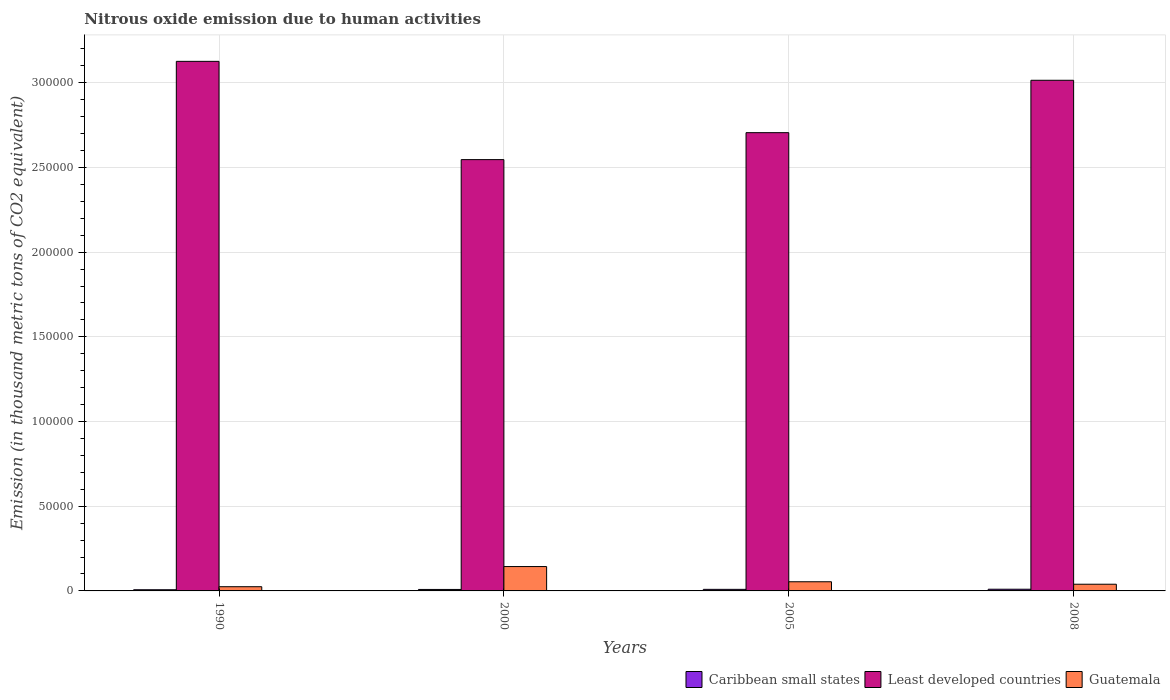How many different coloured bars are there?
Offer a very short reply. 3. How many groups of bars are there?
Your answer should be very brief. 4. Are the number of bars per tick equal to the number of legend labels?
Provide a short and direct response. Yes. Are the number of bars on each tick of the X-axis equal?
Offer a terse response. Yes. How many bars are there on the 1st tick from the left?
Your answer should be compact. 3. How many bars are there on the 4th tick from the right?
Your answer should be compact. 3. What is the amount of nitrous oxide emitted in Guatemala in 1990?
Provide a short and direct response. 2483.4. Across all years, what is the maximum amount of nitrous oxide emitted in Guatemala?
Your response must be concise. 1.44e+04. Across all years, what is the minimum amount of nitrous oxide emitted in Caribbean small states?
Your answer should be very brief. 699.1. In which year was the amount of nitrous oxide emitted in Guatemala maximum?
Offer a terse response. 2000. In which year was the amount of nitrous oxide emitted in Guatemala minimum?
Provide a succinct answer. 1990. What is the total amount of nitrous oxide emitted in Caribbean small states in the graph?
Your answer should be very brief. 3493.5. What is the difference between the amount of nitrous oxide emitted in Guatemala in 2005 and that in 2008?
Your answer should be compact. 1462.9. What is the difference between the amount of nitrous oxide emitted in Least developed countries in 2008 and the amount of nitrous oxide emitted in Guatemala in 2000?
Provide a short and direct response. 2.87e+05. What is the average amount of nitrous oxide emitted in Least developed countries per year?
Offer a terse response. 2.85e+05. In the year 2005, what is the difference between the amount of nitrous oxide emitted in Guatemala and amount of nitrous oxide emitted in Caribbean small states?
Offer a terse response. 4489.8. In how many years, is the amount of nitrous oxide emitted in Guatemala greater than 80000 thousand metric tons?
Give a very brief answer. 0. What is the ratio of the amount of nitrous oxide emitted in Caribbean small states in 1990 to that in 2008?
Keep it short and to the point. 0.7. What is the difference between the highest and the second highest amount of nitrous oxide emitted in Guatemala?
Your response must be concise. 8972.6. What is the difference between the highest and the lowest amount of nitrous oxide emitted in Caribbean small states?
Offer a very short reply. 304.3. In how many years, is the amount of nitrous oxide emitted in Least developed countries greater than the average amount of nitrous oxide emitted in Least developed countries taken over all years?
Provide a short and direct response. 2. What does the 3rd bar from the left in 2008 represents?
Make the answer very short. Guatemala. What does the 2nd bar from the right in 1990 represents?
Offer a very short reply. Least developed countries. Is it the case that in every year, the sum of the amount of nitrous oxide emitted in Least developed countries and amount of nitrous oxide emitted in Guatemala is greater than the amount of nitrous oxide emitted in Caribbean small states?
Provide a succinct answer. Yes. How many bars are there?
Offer a very short reply. 12. How many years are there in the graph?
Make the answer very short. 4. What is the difference between two consecutive major ticks on the Y-axis?
Provide a succinct answer. 5.00e+04. Does the graph contain grids?
Provide a short and direct response. Yes. Where does the legend appear in the graph?
Ensure brevity in your answer.  Bottom right. How many legend labels are there?
Your response must be concise. 3. How are the legend labels stacked?
Keep it short and to the point. Horizontal. What is the title of the graph?
Offer a very short reply. Nitrous oxide emission due to human activities. What is the label or title of the Y-axis?
Provide a succinct answer. Emission (in thousand metric tons of CO2 equivalent). What is the Emission (in thousand metric tons of CO2 equivalent) of Caribbean small states in 1990?
Offer a very short reply. 699.1. What is the Emission (in thousand metric tons of CO2 equivalent) in Least developed countries in 1990?
Keep it short and to the point. 3.13e+05. What is the Emission (in thousand metric tons of CO2 equivalent) of Guatemala in 1990?
Your answer should be compact. 2483.4. What is the Emission (in thousand metric tons of CO2 equivalent) of Caribbean small states in 2000?
Your response must be concise. 867.7. What is the Emission (in thousand metric tons of CO2 equivalent) in Least developed countries in 2000?
Provide a succinct answer. 2.55e+05. What is the Emission (in thousand metric tons of CO2 equivalent) of Guatemala in 2000?
Ensure brevity in your answer.  1.44e+04. What is the Emission (in thousand metric tons of CO2 equivalent) in Caribbean small states in 2005?
Provide a succinct answer. 923.3. What is the Emission (in thousand metric tons of CO2 equivalent) of Least developed countries in 2005?
Offer a very short reply. 2.71e+05. What is the Emission (in thousand metric tons of CO2 equivalent) in Guatemala in 2005?
Ensure brevity in your answer.  5413.1. What is the Emission (in thousand metric tons of CO2 equivalent) in Caribbean small states in 2008?
Your response must be concise. 1003.4. What is the Emission (in thousand metric tons of CO2 equivalent) of Least developed countries in 2008?
Offer a very short reply. 3.02e+05. What is the Emission (in thousand metric tons of CO2 equivalent) in Guatemala in 2008?
Your answer should be compact. 3950.2. Across all years, what is the maximum Emission (in thousand metric tons of CO2 equivalent) in Caribbean small states?
Make the answer very short. 1003.4. Across all years, what is the maximum Emission (in thousand metric tons of CO2 equivalent) in Least developed countries?
Your response must be concise. 3.13e+05. Across all years, what is the maximum Emission (in thousand metric tons of CO2 equivalent) in Guatemala?
Your answer should be compact. 1.44e+04. Across all years, what is the minimum Emission (in thousand metric tons of CO2 equivalent) of Caribbean small states?
Provide a succinct answer. 699.1. Across all years, what is the minimum Emission (in thousand metric tons of CO2 equivalent) of Least developed countries?
Your response must be concise. 2.55e+05. Across all years, what is the minimum Emission (in thousand metric tons of CO2 equivalent) in Guatemala?
Ensure brevity in your answer.  2483.4. What is the total Emission (in thousand metric tons of CO2 equivalent) in Caribbean small states in the graph?
Offer a terse response. 3493.5. What is the total Emission (in thousand metric tons of CO2 equivalent) of Least developed countries in the graph?
Offer a very short reply. 1.14e+06. What is the total Emission (in thousand metric tons of CO2 equivalent) of Guatemala in the graph?
Provide a short and direct response. 2.62e+04. What is the difference between the Emission (in thousand metric tons of CO2 equivalent) of Caribbean small states in 1990 and that in 2000?
Your answer should be compact. -168.6. What is the difference between the Emission (in thousand metric tons of CO2 equivalent) of Least developed countries in 1990 and that in 2000?
Your response must be concise. 5.80e+04. What is the difference between the Emission (in thousand metric tons of CO2 equivalent) in Guatemala in 1990 and that in 2000?
Make the answer very short. -1.19e+04. What is the difference between the Emission (in thousand metric tons of CO2 equivalent) of Caribbean small states in 1990 and that in 2005?
Your response must be concise. -224.2. What is the difference between the Emission (in thousand metric tons of CO2 equivalent) of Least developed countries in 1990 and that in 2005?
Provide a short and direct response. 4.21e+04. What is the difference between the Emission (in thousand metric tons of CO2 equivalent) of Guatemala in 1990 and that in 2005?
Offer a very short reply. -2929.7. What is the difference between the Emission (in thousand metric tons of CO2 equivalent) of Caribbean small states in 1990 and that in 2008?
Give a very brief answer. -304.3. What is the difference between the Emission (in thousand metric tons of CO2 equivalent) of Least developed countries in 1990 and that in 2008?
Give a very brief answer. 1.12e+04. What is the difference between the Emission (in thousand metric tons of CO2 equivalent) of Guatemala in 1990 and that in 2008?
Your response must be concise. -1466.8. What is the difference between the Emission (in thousand metric tons of CO2 equivalent) in Caribbean small states in 2000 and that in 2005?
Offer a very short reply. -55.6. What is the difference between the Emission (in thousand metric tons of CO2 equivalent) in Least developed countries in 2000 and that in 2005?
Ensure brevity in your answer.  -1.59e+04. What is the difference between the Emission (in thousand metric tons of CO2 equivalent) in Guatemala in 2000 and that in 2005?
Ensure brevity in your answer.  8972.6. What is the difference between the Emission (in thousand metric tons of CO2 equivalent) in Caribbean small states in 2000 and that in 2008?
Offer a terse response. -135.7. What is the difference between the Emission (in thousand metric tons of CO2 equivalent) in Least developed countries in 2000 and that in 2008?
Provide a succinct answer. -4.69e+04. What is the difference between the Emission (in thousand metric tons of CO2 equivalent) of Guatemala in 2000 and that in 2008?
Your answer should be very brief. 1.04e+04. What is the difference between the Emission (in thousand metric tons of CO2 equivalent) of Caribbean small states in 2005 and that in 2008?
Keep it short and to the point. -80.1. What is the difference between the Emission (in thousand metric tons of CO2 equivalent) of Least developed countries in 2005 and that in 2008?
Offer a very short reply. -3.09e+04. What is the difference between the Emission (in thousand metric tons of CO2 equivalent) in Guatemala in 2005 and that in 2008?
Give a very brief answer. 1462.9. What is the difference between the Emission (in thousand metric tons of CO2 equivalent) of Caribbean small states in 1990 and the Emission (in thousand metric tons of CO2 equivalent) of Least developed countries in 2000?
Ensure brevity in your answer.  -2.54e+05. What is the difference between the Emission (in thousand metric tons of CO2 equivalent) of Caribbean small states in 1990 and the Emission (in thousand metric tons of CO2 equivalent) of Guatemala in 2000?
Provide a succinct answer. -1.37e+04. What is the difference between the Emission (in thousand metric tons of CO2 equivalent) of Least developed countries in 1990 and the Emission (in thousand metric tons of CO2 equivalent) of Guatemala in 2000?
Offer a very short reply. 2.98e+05. What is the difference between the Emission (in thousand metric tons of CO2 equivalent) of Caribbean small states in 1990 and the Emission (in thousand metric tons of CO2 equivalent) of Least developed countries in 2005?
Offer a terse response. -2.70e+05. What is the difference between the Emission (in thousand metric tons of CO2 equivalent) in Caribbean small states in 1990 and the Emission (in thousand metric tons of CO2 equivalent) in Guatemala in 2005?
Provide a short and direct response. -4714. What is the difference between the Emission (in thousand metric tons of CO2 equivalent) of Least developed countries in 1990 and the Emission (in thousand metric tons of CO2 equivalent) of Guatemala in 2005?
Offer a very short reply. 3.07e+05. What is the difference between the Emission (in thousand metric tons of CO2 equivalent) in Caribbean small states in 1990 and the Emission (in thousand metric tons of CO2 equivalent) in Least developed countries in 2008?
Your answer should be very brief. -3.01e+05. What is the difference between the Emission (in thousand metric tons of CO2 equivalent) in Caribbean small states in 1990 and the Emission (in thousand metric tons of CO2 equivalent) in Guatemala in 2008?
Ensure brevity in your answer.  -3251.1. What is the difference between the Emission (in thousand metric tons of CO2 equivalent) in Least developed countries in 1990 and the Emission (in thousand metric tons of CO2 equivalent) in Guatemala in 2008?
Keep it short and to the point. 3.09e+05. What is the difference between the Emission (in thousand metric tons of CO2 equivalent) of Caribbean small states in 2000 and the Emission (in thousand metric tons of CO2 equivalent) of Least developed countries in 2005?
Your answer should be very brief. -2.70e+05. What is the difference between the Emission (in thousand metric tons of CO2 equivalent) of Caribbean small states in 2000 and the Emission (in thousand metric tons of CO2 equivalent) of Guatemala in 2005?
Offer a very short reply. -4545.4. What is the difference between the Emission (in thousand metric tons of CO2 equivalent) of Least developed countries in 2000 and the Emission (in thousand metric tons of CO2 equivalent) of Guatemala in 2005?
Offer a terse response. 2.49e+05. What is the difference between the Emission (in thousand metric tons of CO2 equivalent) in Caribbean small states in 2000 and the Emission (in thousand metric tons of CO2 equivalent) in Least developed countries in 2008?
Your response must be concise. -3.01e+05. What is the difference between the Emission (in thousand metric tons of CO2 equivalent) of Caribbean small states in 2000 and the Emission (in thousand metric tons of CO2 equivalent) of Guatemala in 2008?
Your response must be concise. -3082.5. What is the difference between the Emission (in thousand metric tons of CO2 equivalent) of Least developed countries in 2000 and the Emission (in thousand metric tons of CO2 equivalent) of Guatemala in 2008?
Your answer should be compact. 2.51e+05. What is the difference between the Emission (in thousand metric tons of CO2 equivalent) in Caribbean small states in 2005 and the Emission (in thousand metric tons of CO2 equivalent) in Least developed countries in 2008?
Keep it short and to the point. -3.01e+05. What is the difference between the Emission (in thousand metric tons of CO2 equivalent) in Caribbean small states in 2005 and the Emission (in thousand metric tons of CO2 equivalent) in Guatemala in 2008?
Provide a succinct answer. -3026.9. What is the difference between the Emission (in thousand metric tons of CO2 equivalent) of Least developed countries in 2005 and the Emission (in thousand metric tons of CO2 equivalent) of Guatemala in 2008?
Provide a succinct answer. 2.67e+05. What is the average Emission (in thousand metric tons of CO2 equivalent) of Caribbean small states per year?
Offer a very short reply. 873.38. What is the average Emission (in thousand metric tons of CO2 equivalent) in Least developed countries per year?
Offer a terse response. 2.85e+05. What is the average Emission (in thousand metric tons of CO2 equivalent) of Guatemala per year?
Your response must be concise. 6558.1. In the year 1990, what is the difference between the Emission (in thousand metric tons of CO2 equivalent) of Caribbean small states and Emission (in thousand metric tons of CO2 equivalent) of Least developed countries?
Make the answer very short. -3.12e+05. In the year 1990, what is the difference between the Emission (in thousand metric tons of CO2 equivalent) of Caribbean small states and Emission (in thousand metric tons of CO2 equivalent) of Guatemala?
Keep it short and to the point. -1784.3. In the year 1990, what is the difference between the Emission (in thousand metric tons of CO2 equivalent) of Least developed countries and Emission (in thousand metric tons of CO2 equivalent) of Guatemala?
Offer a terse response. 3.10e+05. In the year 2000, what is the difference between the Emission (in thousand metric tons of CO2 equivalent) in Caribbean small states and Emission (in thousand metric tons of CO2 equivalent) in Least developed countries?
Provide a succinct answer. -2.54e+05. In the year 2000, what is the difference between the Emission (in thousand metric tons of CO2 equivalent) in Caribbean small states and Emission (in thousand metric tons of CO2 equivalent) in Guatemala?
Make the answer very short. -1.35e+04. In the year 2000, what is the difference between the Emission (in thousand metric tons of CO2 equivalent) of Least developed countries and Emission (in thousand metric tons of CO2 equivalent) of Guatemala?
Ensure brevity in your answer.  2.40e+05. In the year 2005, what is the difference between the Emission (in thousand metric tons of CO2 equivalent) of Caribbean small states and Emission (in thousand metric tons of CO2 equivalent) of Least developed countries?
Ensure brevity in your answer.  -2.70e+05. In the year 2005, what is the difference between the Emission (in thousand metric tons of CO2 equivalent) in Caribbean small states and Emission (in thousand metric tons of CO2 equivalent) in Guatemala?
Keep it short and to the point. -4489.8. In the year 2005, what is the difference between the Emission (in thousand metric tons of CO2 equivalent) in Least developed countries and Emission (in thousand metric tons of CO2 equivalent) in Guatemala?
Ensure brevity in your answer.  2.65e+05. In the year 2008, what is the difference between the Emission (in thousand metric tons of CO2 equivalent) of Caribbean small states and Emission (in thousand metric tons of CO2 equivalent) of Least developed countries?
Offer a very short reply. -3.01e+05. In the year 2008, what is the difference between the Emission (in thousand metric tons of CO2 equivalent) in Caribbean small states and Emission (in thousand metric tons of CO2 equivalent) in Guatemala?
Your answer should be very brief. -2946.8. In the year 2008, what is the difference between the Emission (in thousand metric tons of CO2 equivalent) of Least developed countries and Emission (in thousand metric tons of CO2 equivalent) of Guatemala?
Offer a very short reply. 2.98e+05. What is the ratio of the Emission (in thousand metric tons of CO2 equivalent) of Caribbean small states in 1990 to that in 2000?
Your answer should be compact. 0.81. What is the ratio of the Emission (in thousand metric tons of CO2 equivalent) of Least developed countries in 1990 to that in 2000?
Offer a terse response. 1.23. What is the ratio of the Emission (in thousand metric tons of CO2 equivalent) in Guatemala in 1990 to that in 2000?
Provide a succinct answer. 0.17. What is the ratio of the Emission (in thousand metric tons of CO2 equivalent) of Caribbean small states in 1990 to that in 2005?
Provide a succinct answer. 0.76. What is the ratio of the Emission (in thousand metric tons of CO2 equivalent) of Least developed countries in 1990 to that in 2005?
Keep it short and to the point. 1.16. What is the ratio of the Emission (in thousand metric tons of CO2 equivalent) in Guatemala in 1990 to that in 2005?
Provide a short and direct response. 0.46. What is the ratio of the Emission (in thousand metric tons of CO2 equivalent) in Caribbean small states in 1990 to that in 2008?
Provide a succinct answer. 0.7. What is the ratio of the Emission (in thousand metric tons of CO2 equivalent) of Guatemala in 1990 to that in 2008?
Offer a very short reply. 0.63. What is the ratio of the Emission (in thousand metric tons of CO2 equivalent) of Caribbean small states in 2000 to that in 2005?
Your answer should be compact. 0.94. What is the ratio of the Emission (in thousand metric tons of CO2 equivalent) in Least developed countries in 2000 to that in 2005?
Make the answer very short. 0.94. What is the ratio of the Emission (in thousand metric tons of CO2 equivalent) in Guatemala in 2000 to that in 2005?
Make the answer very short. 2.66. What is the ratio of the Emission (in thousand metric tons of CO2 equivalent) of Caribbean small states in 2000 to that in 2008?
Make the answer very short. 0.86. What is the ratio of the Emission (in thousand metric tons of CO2 equivalent) in Least developed countries in 2000 to that in 2008?
Your answer should be very brief. 0.84. What is the ratio of the Emission (in thousand metric tons of CO2 equivalent) of Guatemala in 2000 to that in 2008?
Give a very brief answer. 3.64. What is the ratio of the Emission (in thousand metric tons of CO2 equivalent) in Caribbean small states in 2005 to that in 2008?
Provide a short and direct response. 0.92. What is the ratio of the Emission (in thousand metric tons of CO2 equivalent) of Least developed countries in 2005 to that in 2008?
Keep it short and to the point. 0.9. What is the ratio of the Emission (in thousand metric tons of CO2 equivalent) in Guatemala in 2005 to that in 2008?
Make the answer very short. 1.37. What is the difference between the highest and the second highest Emission (in thousand metric tons of CO2 equivalent) in Caribbean small states?
Provide a succinct answer. 80.1. What is the difference between the highest and the second highest Emission (in thousand metric tons of CO2 equivalent) in Least developed countries?
Provide a short and direct response. 1.12e+04. What is the difference between the highest and the second highest Emission (in thousand metric tons of CO2 equivalent) of Guatemala?
Give a very brief answer. 8972.6. What is the difference between the highest and the lowest Emission (in thousand metric tons of CO2 equivalent) of Caribbean small states?
Your response must be concise. 304.3. What is the difference between the highest and the lowest Emission (in thousand metric tons of CO2 equivalent) in Least developed countries?
Offer a very short reply. 5.80e+04. What is the difference between the highest and the lowest Emission (in thousand metric tons of CO2 equivalent) of Guatemala?
Keep it short and to the point. 1.19e+04. 